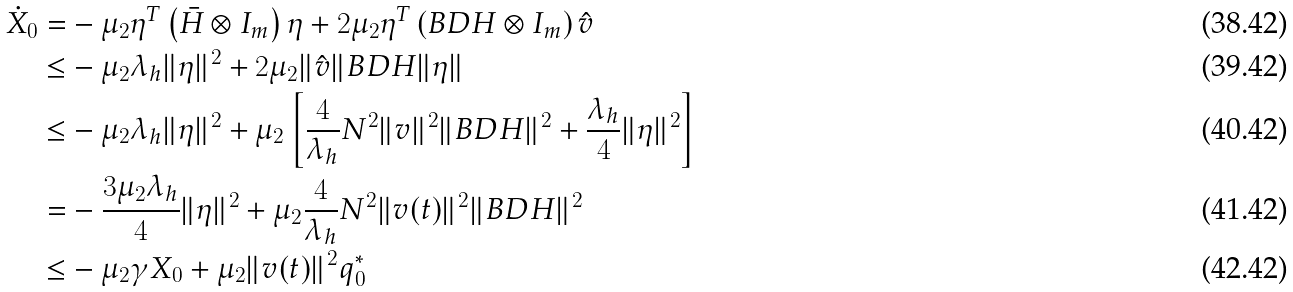<formula> <loc_0><loc_0><loc_500><loc_500>\dot { X } _ { 0 } = & - \mu _ { 2 } \eta ^ { T } \left ( \bar { H } \otimes I _ { m } \right ) \eta + 2 \mu _ { 2 } \eta ^ { T } \left ( B D H \otimes I _ { m } \right ) \hat { v } \\ \leq & - \mu _ { 2 } \lambda _ { h } \| \eta \| ^ { 2 } + 2 \mu _ { 2 } \| \hat { v } \| B D H \| \eta \| \\ \leq & - \mu _ { 2 } \lambda _ { h } \| \eta \| ^ { 2 } + \mu _ { 2 } \left [ \frac { 4 } { \lambda _ { h } } N ^ { 2 } \| v \| ^ { 2 } \| B D H \| ^ { 2 } + \frac { \lambda _ { h } } { 4 } \| \eta \| ^ { 2 } \right ] \\ = & - \frac { 3 \mu _ { 2 } \lambda _ { h } } { 4 } \| \eta \| ^ { 2 } + \mu _ { 2 } \frac { 4 } { \lambda _ { h } } N ^ { 2 } \| v ( t ) \| ^ { 2 } \| B D H \| ^ { 2 } \\ \leq & - \mu _ { 2 } \gamma X _ { 0 } + \mu _ { 2 } \| v ( t ) \| ^ { 2 } q _ { 0 } ^ { * }</formula> 